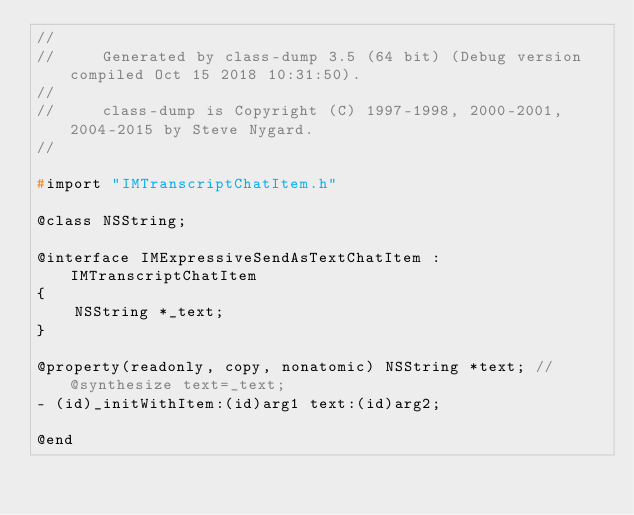Convert code to text. <code><loc_0><loc_0><loc_500><loc_500><_C_>//
//     Generated by class-dump 3.5 (64 bit) (Debug version compiled Oct 15 2018 10:31:50).
//
//     class-dump is Copyright (C) 1997-1998, 2000-2001, 2004-2015 by Steve Nygard.
//

#import "IMTranscriptChatItem.h"

@class NSString;

@interface IMExpressiveSendAsTextChatItem : IMTranscriptChatItem
{
    NSString *_text;
}

@property(readonly, copy, nonatomic) NSString *text; // @synthesize text=_text;
- (id)_initWithItem:(id)arg1 text:(id)arg2;

@end

</code> 